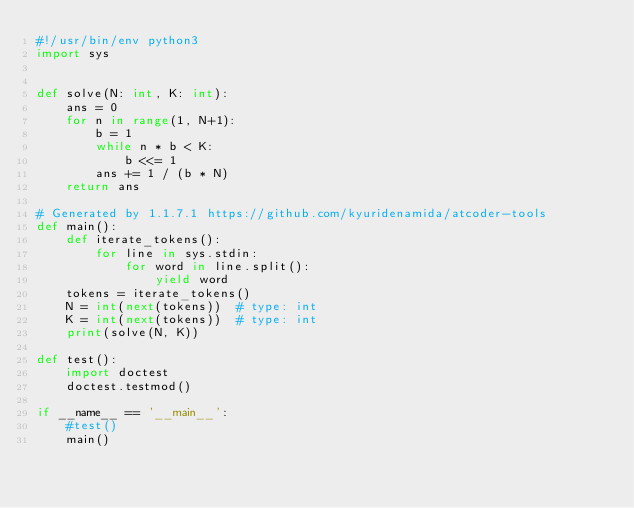Convert code to text. <code><loc_0><loc_0><loc_500><loc_500><_Python_>#!/usr/bin/env python3
import sys


def solve(N: int, K: int):
    ans = 0
    for n in range(1, N+1):
        b = 1
        while n * b < K:
            b <<= 1
        ans += 1 / (b * N)
    return ans

# Generated by 1.1.7.1 https://github.com/kyuridenamida/atcoder-tools
def main():
    def iterate_tokens():
        for line in sys.stdin:
            for word in line.split():
                yield word
    tokens = iterate_tokens()
    N = int(next(tokens))  # type: int
    K = int(next(tokens))  # type: int
    print(solve(N, K))

def test():
    import doctest
    doctest.testmod()

if __name__ == '__main__':
    #test()
    main()
</code> 